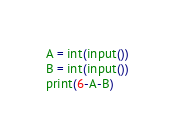<code> <loc_0><loc_0><loc_500><loc_500><_Python_>A = int(input())
B = int(input())
print(6-A-B)</code> 